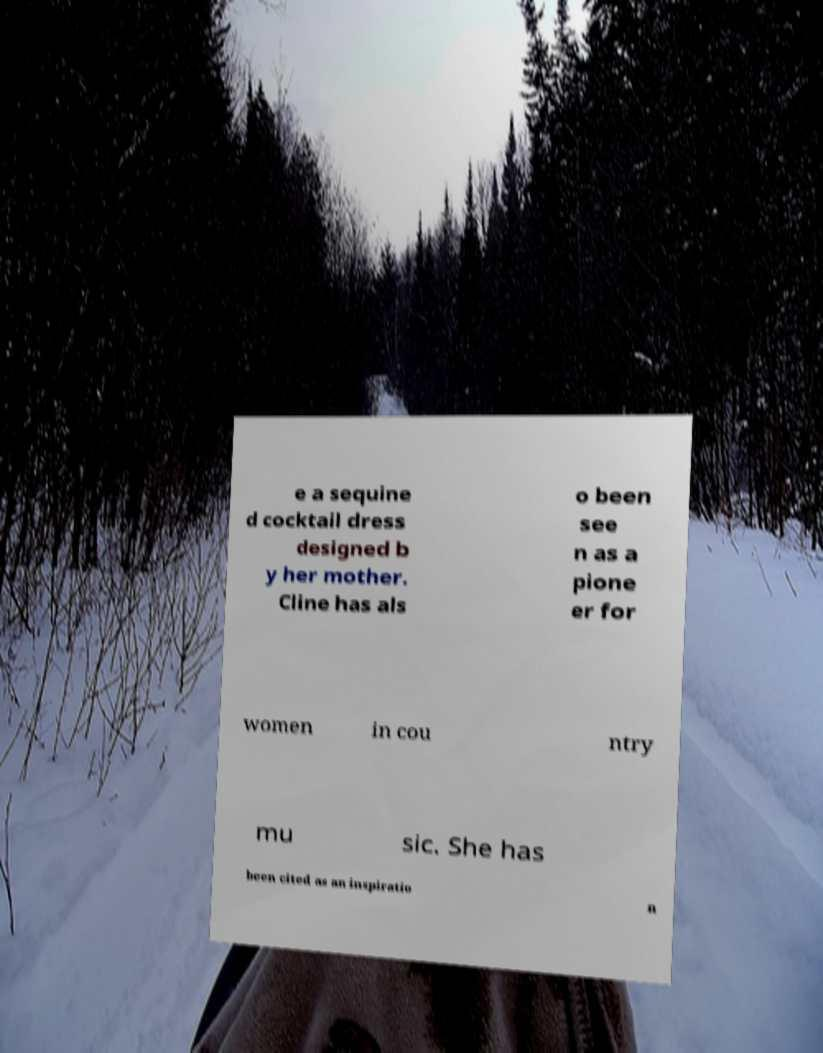Can you accurately transcribe the text from the provided image for me? e a sequine d cocktail dress designed b y her mother. Cline has als o been see n as a pione er for women in cou ntry mu sic. She has been cited as an inspiratio n 